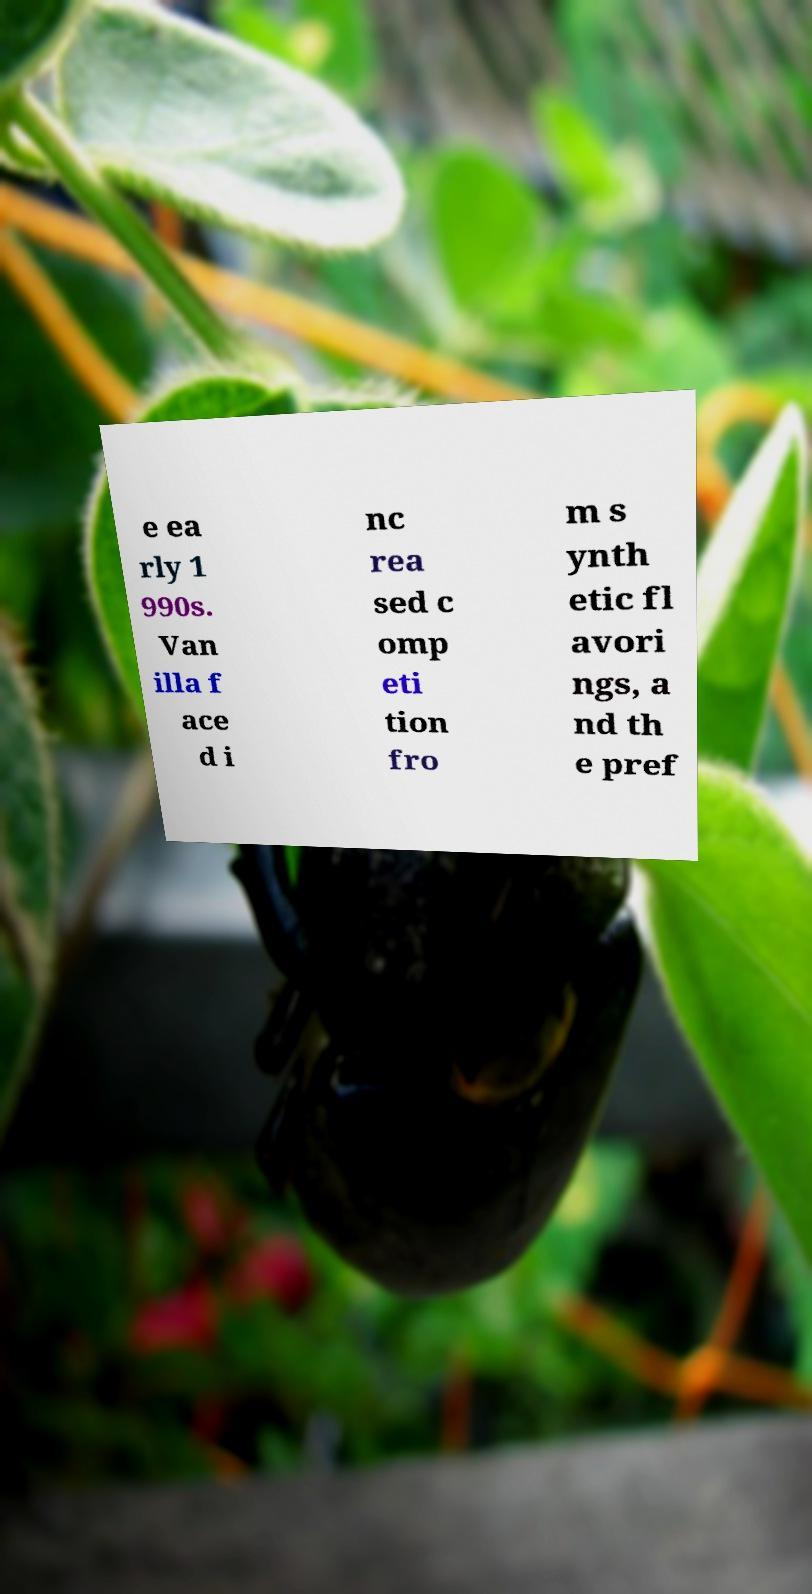Can you read and provide the text displayed in the image?This photo seems to have some interesting text. Can you extract and type it out for me? e ea rly 1 990s. Van illa f ace d i nc rea sed c omp eti tion fro m s ynth etic fl avori ngs, a nd th e pref 